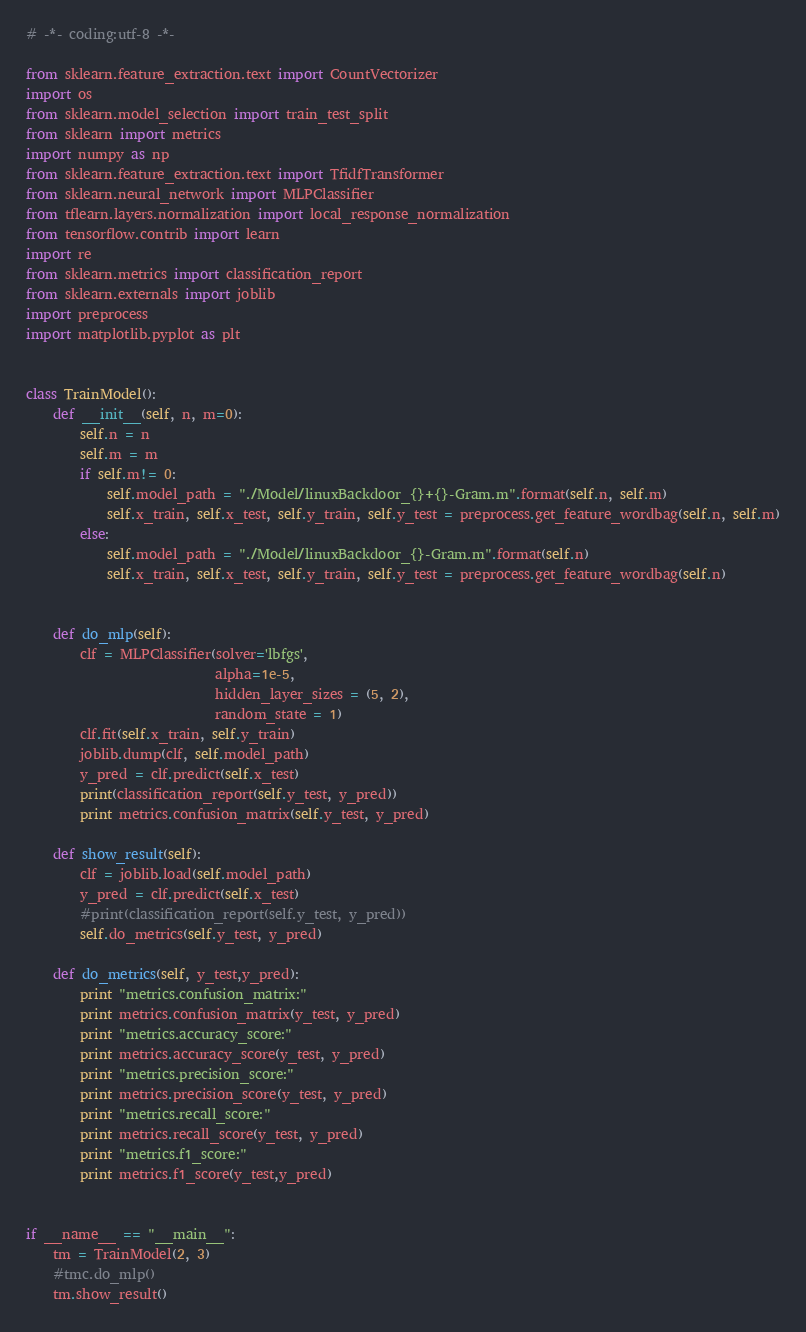Convert code to text. <code><loc_0><loc_0><loc_500><loc_500><_Python_># -*- coding:utf-8 -*-

from sklearn.feature_extraction.text import CountVectorizer
import os
from sklearn.model_selection import train_test_split
from sklearn import metrics
import numpy as np
from sklearn.feature_extraction.text import TfidfTransformer
from sklearn.neural_network import MLPClassifier
from tflearn.layers.normalization import local_response_normalization
from tensorflow.contrib import learn
import re
from sklearn.metrics import classification_report
from sklearn.externals import joblib
import preprocess
import matplotlib.pyplot as plt


class TrainModel():
    def __init__(self, n, m=0):
        self.n = n
        self.m = m
        if self.m!= 0:
            self.model_path = "./Model/linuxBackdoor_{}+{}-Gram.m".format(self.n, self.m)
            self.x_train, self.x_test, self.y_train, self.y_test = preprocess.get_feature_wordbag(self.n, self.m)
        else:
            self.model_path = "./Model/linuxBackdoor_{}-Gram.m".format(self.n)
            self.x_train, self.x_test, self.y_train, self.y_test = preprocess.get_feature_wordbag(self.n)


    def do_mlp(self):
        clf = MLPClassifier(solver='lbfgs',
                            alpha=1e-5,
                            hidden_layer_sizes = (5, 2),
                            random_state = 1)
        clf.fit(self.x_train, self.y_train)
        joblib.dump(clf, self.model_path)
        y_pred = clf.predict(self.x_test)
        print(classification_report(self.y_test, y_pred))
        print metrics.confusion_matrix(self.y_test, y_pred)

    def show_result(self):
        clf = joblib.load(self.model_path)
        y_pred = clf.predict(self.x_test)
        #print(classification_report(self.y_test, y_pred))
        self.do_metrics(self.y_test, y_pred)

    def do_metrics(self, y_test,y_pred):
        print "metrics.confusion_matrix:"
        print metrics.confusion_matrix(y_test, y_pred)
        print "metrics.accuracy_score:"
        print metrics.accuracy_score(y_test, y_pred)
        print "metrics.precision_score:"
        print metrics.precision_score(y_test, y_pred)
        print "metrics.recall_score:"
        print metrics.recall_score(y_test, y_pred)
        print "metrics.f1_score:"
        print metrics.f1_score(y_test,y_pred)


if __name__ == "__main__":
    tm = TrainModel(2, 3)
    #tmc.do_mlp()
    tm.show_result()
</code> 